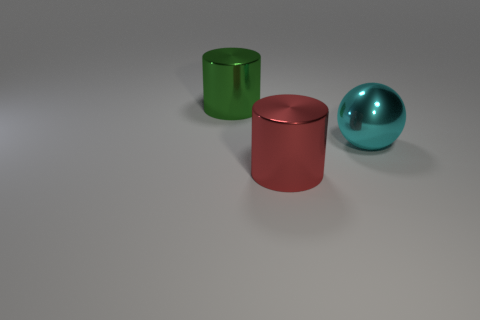Add 2 large metal objects. How many objects exist? 5 Subtract all cylinders. How many objects are left? 1 Subtract all cylinders. Subtract all large cyan balls. How many objects are left? 0 Add 1 big red cylinders. How many big red cylinders are left? 2 Add 2 large yellow things. How many large yellow things exist? 2 Subtract 0 brown cylinders. How many objects are left? 3 